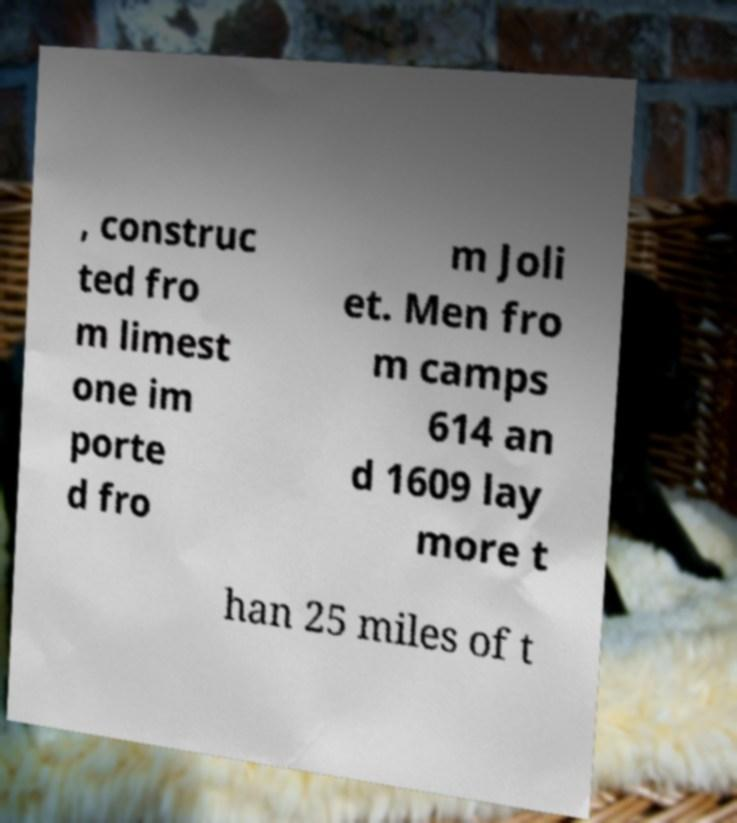What messages or text are displayed in this image? I need them in a readable, typed format. , construc ted fro m limest one im porte d fro m Joli et. Men fro m camps 614 an d 1609 lay more t han 25 miles of t 